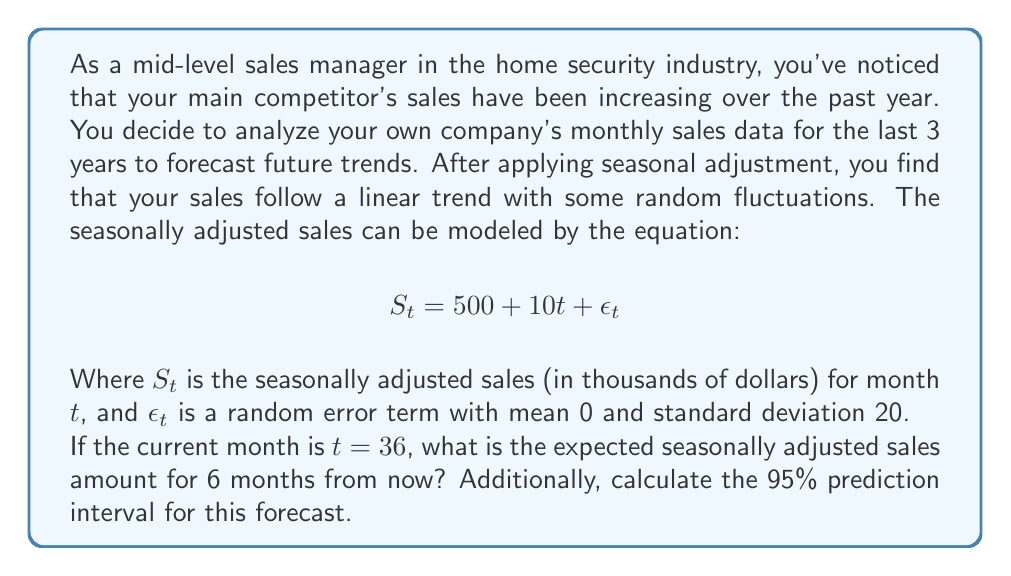Help me with this question. To solve this problem, we'll follow these steps:

1. Calculate the point forecast for 6 months from now:
   - Current month: $t = 36$
   - Forecast month: $t = 36 + 6 = 42$
   - Use the given equation: $S_t = 500 + 10t + \epsilon_t$
   - Substitute $t = 42$: $S_{42} = 500 + 10(42) + \epsilon_{42}$
   - $\mathbb{E}[S_{42}] = 500 + 420 = 920$ (since $\mathbb{E}[\epsilon_t] = 0$)

2. Calculate the standard error of the forecast:
   - The standard error is equal to the standard deviation of $\epsilon_t$, which is given as 20.

3. Calculate the 95% prediction interval:
   - For a 95% interval, we use a z-score of approximately 1.96
   - The interval is: $\text{Point Forecast} \pm 1.96 \times \text{Standard Error}$
   - Lower bound: $920 - 1.96 \times 20 = 920 - 39.2 = 880.8$
   - Upper bound: $920 + 1.96 \times 20 = 920 + 39.2 = 959.2$

Therefore, the point forecast for 6 months from now is $920,000, and the 95% prediction interval is ($880,800, $959,200).
Answer: The expected seasonally adjusted sales amount for 6 months from now is $920,000. The 95% prediction interval for this forecast is ($880,800, $959,200). 